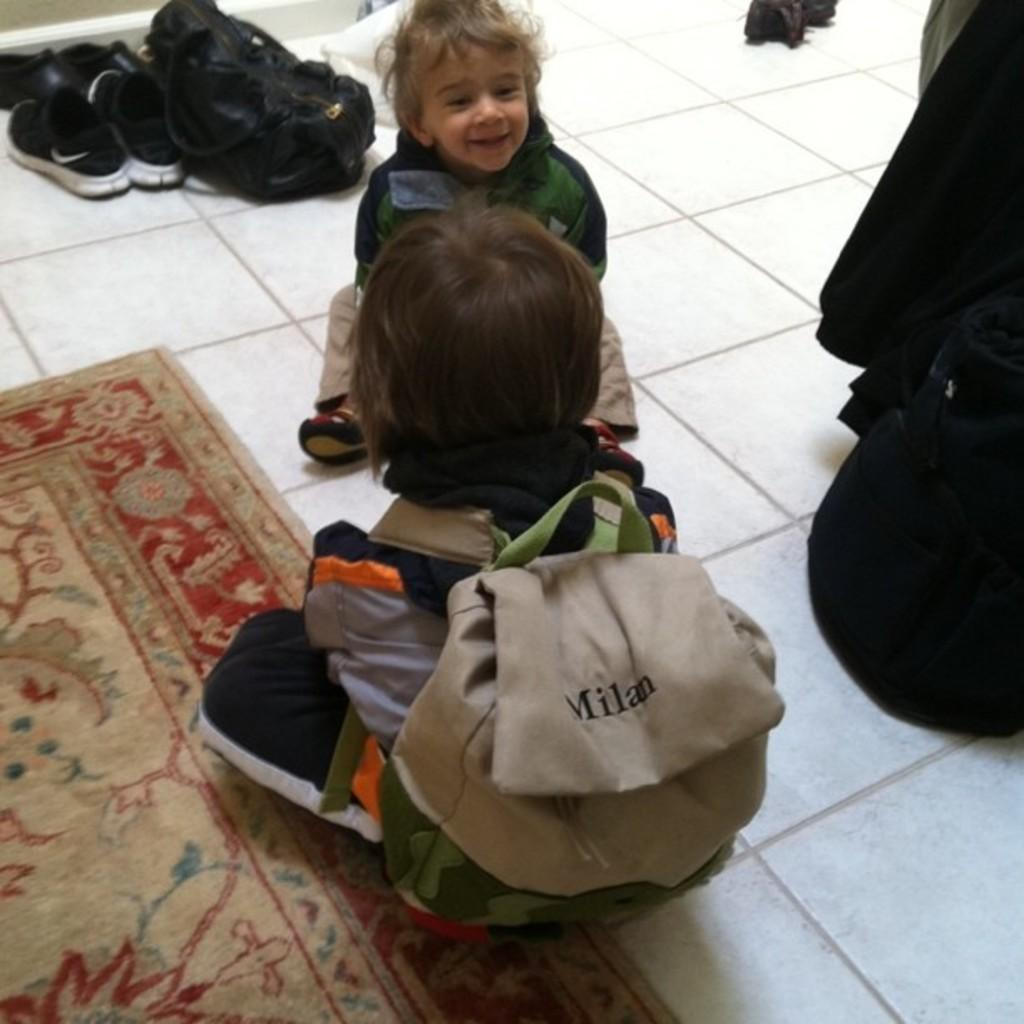<image>
Give a short and clear explanation of the subsequent image. two toddlers and one has a backpack with Milan on it. 